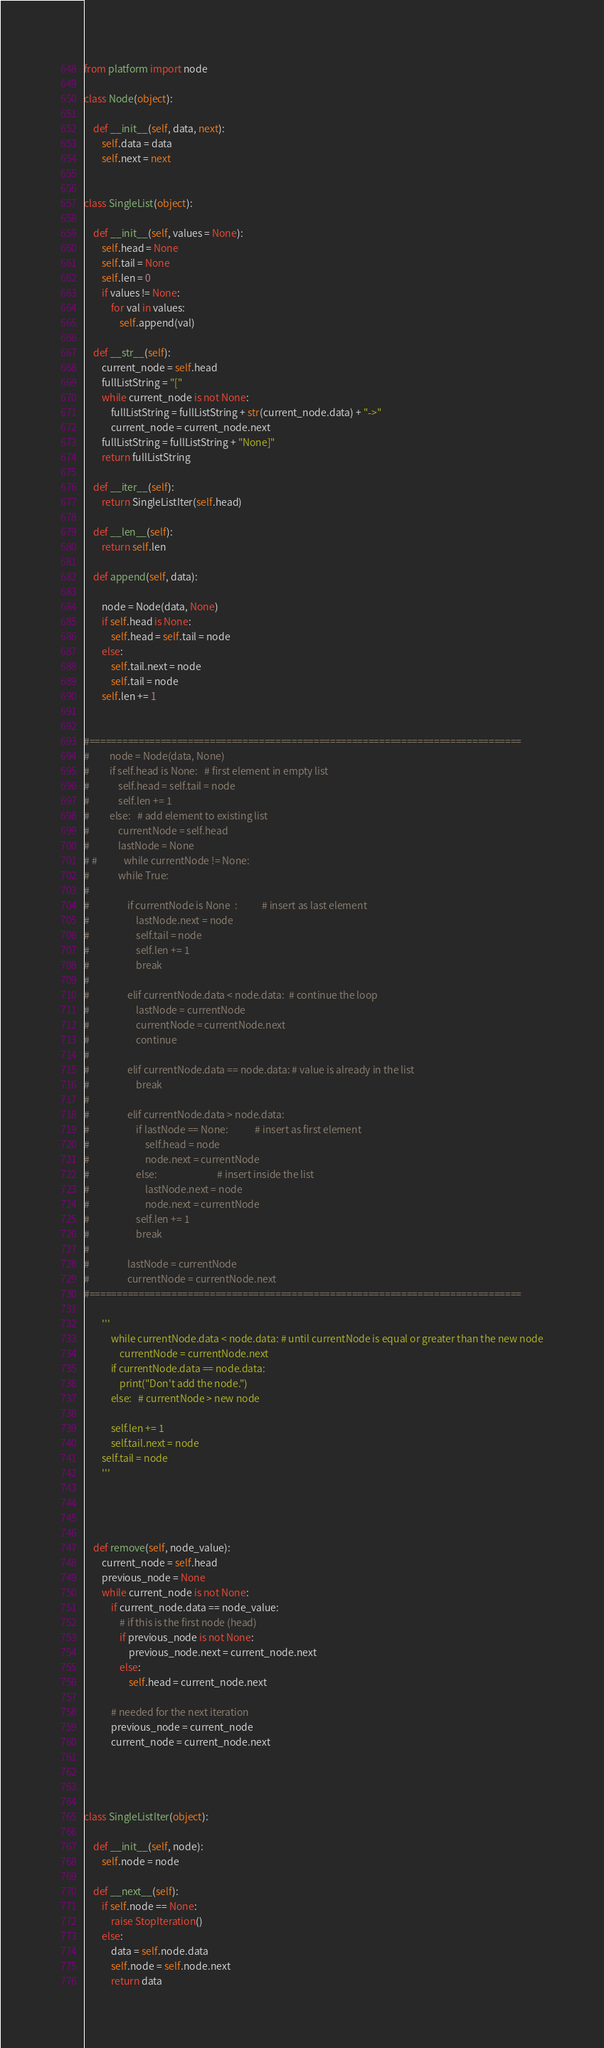Convert code to text. <code><loc_0><loc_0><loc_500><loc_500><_Python_>from platform import node

class Node(object):
 
    def __init__(self, data, next):
        self.data = data
        self.next = next
 
 
class SingleList(object):
 
    def __init__(self, values = None):
        self.head = None
        self.tail = None
        self.len = 0
        if values != None:
            for val in values:
                self.append(val)
 
    def __str__(self):
        current_node = self.head
        fullListString = "["
        while current_node is not None:
            fullListString = fullListString + str(current_node.data) + "->"
            current_node = current_node.next
        fullListString = fullListString + "None]"
        return fullListString
 
    def __iter__(self):
        return SingleListIter(self.head)
    
    def __len__(self):
        return self.len
    
    def append(self, data):
        
        node = Node(data, None)
        if self.head is None:
            self.head = self.tail = node
        else:
            self.tail.next = node
            self.tail = node
        self.len += 1
        
        
#===============================================================================
#         node = Node(data, None)
#         if self.head is None:   # first element in empty list
#             self.head = self.tail = node
#             self.len += 1
#         else:   # add element to existing list
#             currentNode = self.head
#             lastNode = None
# #            while currentNode != None:
#             while True:
#                 
#                 if currentNode is None  :           # insert as last element
#                     lastNode.next = node
#                     self.tail = node
#                     self.len += 1
#                     break
#                     
#                 elif currentNode.data < node.data:  # continue the loop
#                     lastNode = currentNode
#                     currentNode = currentNode.next
#                     continue
#                     
#                 elif currentNode.data == node.data: # value is already in the list
#                     break
#                 
#                 elif currentNode.data > node.data:
#                     if lastNode == None:            # insert as first element
#                         self.head = node
#                         node.next = currentNode
#                     else:                           # insert inside the list
#                         lastNode.next = node
#                         node.next = currentNode
#                     self.len += 1
#                     break
#                     
#                 lastNode = currentNode
#                 currentNode = currentNode.next
#===============================================================================

        '''
            while currentNode.data < node.data: # until currentNode is equal or greater than the new node
                currentNode = currentNode.next
            if currentNode.data == node.data:
                print("Don't add the node.")
            else:   # currentNode > new node
                
            self.len += 1
            self.tail.next = node
        self.tail = node
        '''
    
        
    

    def remove(self, node_value):
        current_node = self.head
        previous_node = None
        while current_node is not None:
            if current_node.data == node_value:
                # if this is the first node (head)
                if previous_node is not None:
                    previous_node.next = current_node.next
                else:
                    self.head = current_node.next
 
            # needed for the next iteration
            previous_node = current_node
            current_node = current_node.next




class SingleListIter(object):

    def __init__(self, node):
        self.node = node
 
    def __next__(self):
        if self.node == None:
            raise StopIteration()
        else:
            data = self.node.data
            self.node = self.node.next
            return data</code> 